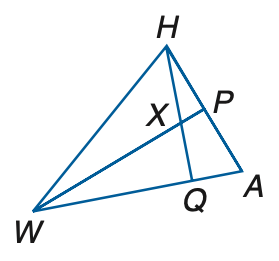Answer the mathemtical geometry problem and directly provide the correct option letter.
Question: If W P is a median and an angle bisector, A P = 3 y + 11, P H = 7 y - 5, m \angle H W P = x + 12, m \angle P A W = 3 x - 2, and m \angle H W A = 4 x - 16, find x.
Choices: A: 20 B: 24 C: 28 D: 32 A 